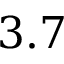Convert formula to latex. <formula><loc_0><loc_0><loc_500><loc_500>3 . 7</formula> 